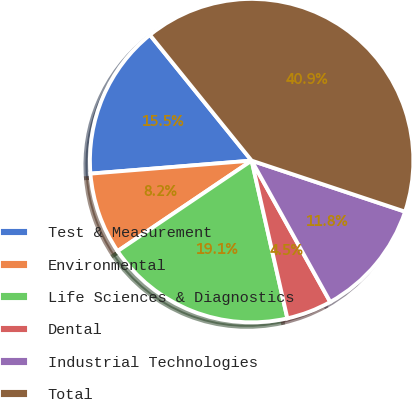Convert chart to OTSL. <chart><loc_0><loc_0><loc_500><loc_500><pie_chart><fcel>Test & Measurement<fcel>Environmental<fcel>Life Sciences & Diagnostics<fcel>Dental<fcel>Industrial Technologies<fcel>Total<nl><fcel>15.45%<fcel>8.17%<fcel>19.09%<fcel>4.53%<fcel>11.81%<fcel>40.93%<nl></chart> 